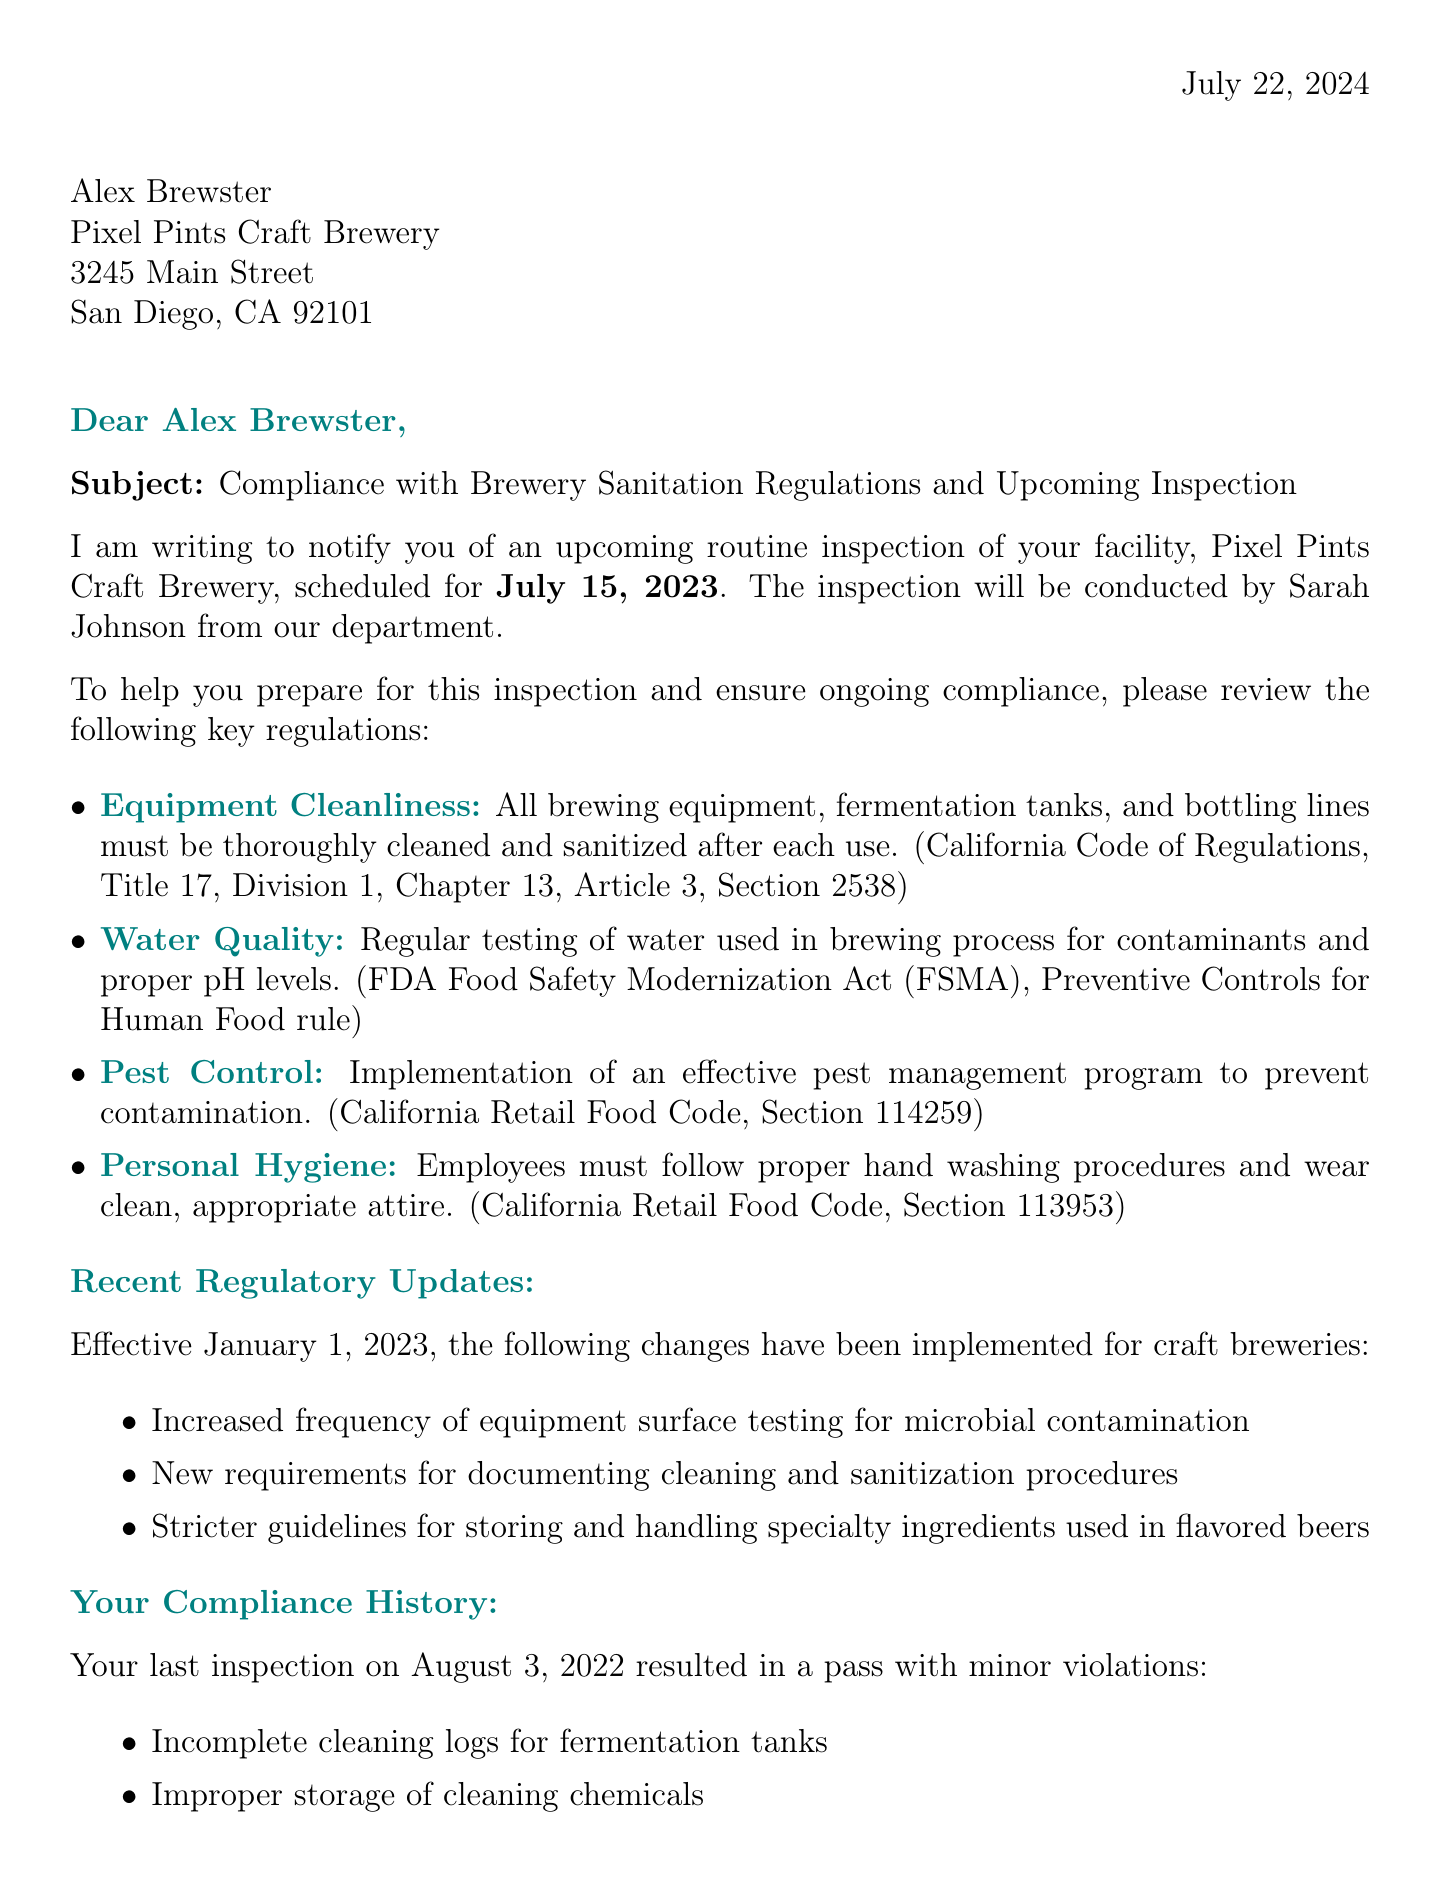What is the inspection date? The inspection date is specifically mentioned in the introduction section of the letter.
Answer: July 15, 2023 Who is the inspector? The name of the inspector is provided in the introduction of the letter.
Answer: Sarah Johnson What are the recent regulatory changes effective date? This information is specifically stated in the recent changes section of the letter.
Answer: January 1, 2023 What was the result of the last inspection? The result of the last inspection can be found in the compliance history section.
Answer: Pass with minor violations What is one preparation tip for the inspection? The letter provides a list of preparation tips in its preparation tips section.
Answer: Review and update your Sanitation Standard Operating Procedures (SSOPs) What is the purpose of the letter? The purpose of the letter is mentioned at the beginning, summarizing the intent of the correspondence.
Answer: Notify of upcoming routine inspection and review current sanitation regulations Which department sent this letter? The department sending the letter is specified at the top of the document.
Answer: San Diego County Department of Environmental Health What is the phone number for the contact person? The contact person's phone number is given in the conclusion section of the letter.
Answer: (858) 505-6900 ext. 123 